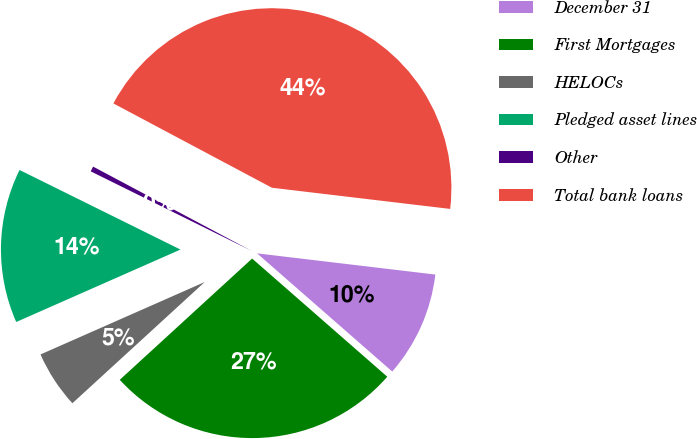Convert chart to OTSL. <chart><loc_0><loc_0><loc_500><loc_500><pie_chart><fcel>December 31<fcel>First Mortgages<fcel>HELOCs<fcel>Pledged asset lines<fcel>Other<fcel>Total bank loans<nl><fcel>9.55%<fcel>26.76%<fcel>5.19%<fcel>13.92%<fcel>0.47%<fcel>44.1%<nl></chart> 